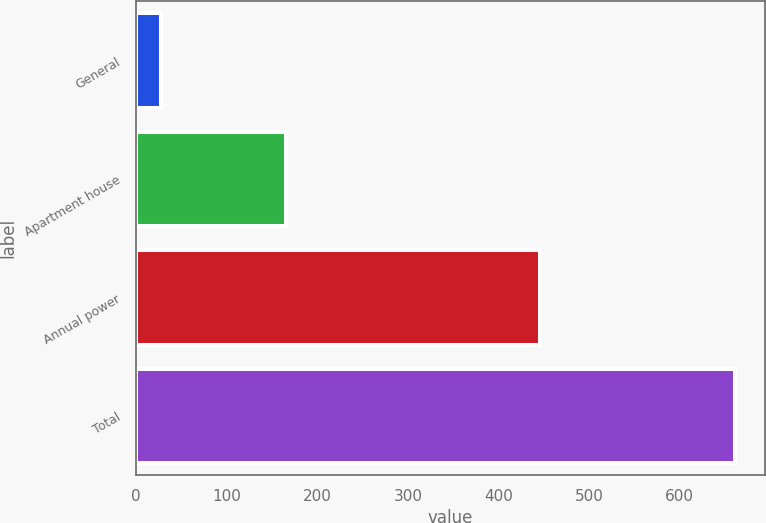Convert chart. <chart><loc_0><loc_0><loc_500><loc_500><bar_chart><fcel>General<fcel>Apartment house<fcel>Annual power<fcel>Total<nl><fcel>28<fcel>165<fcel>446<fcel>661<nl></chart> 